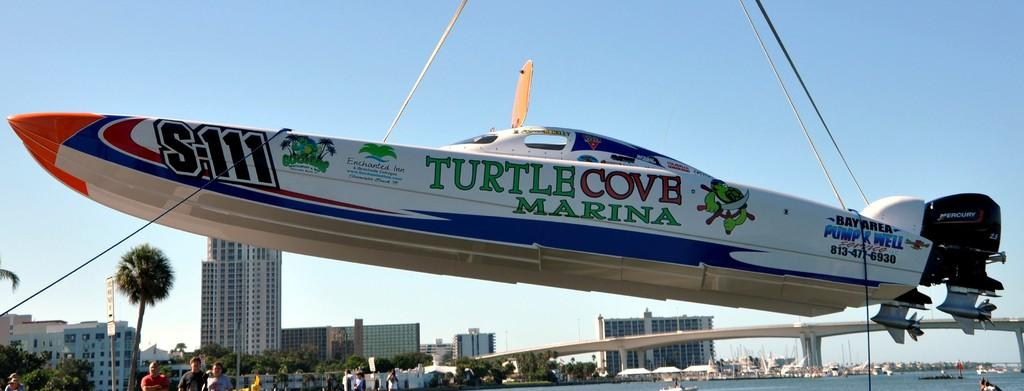Provide a one-sentence caption for the provided image. a plane that has the word turtle on it. 